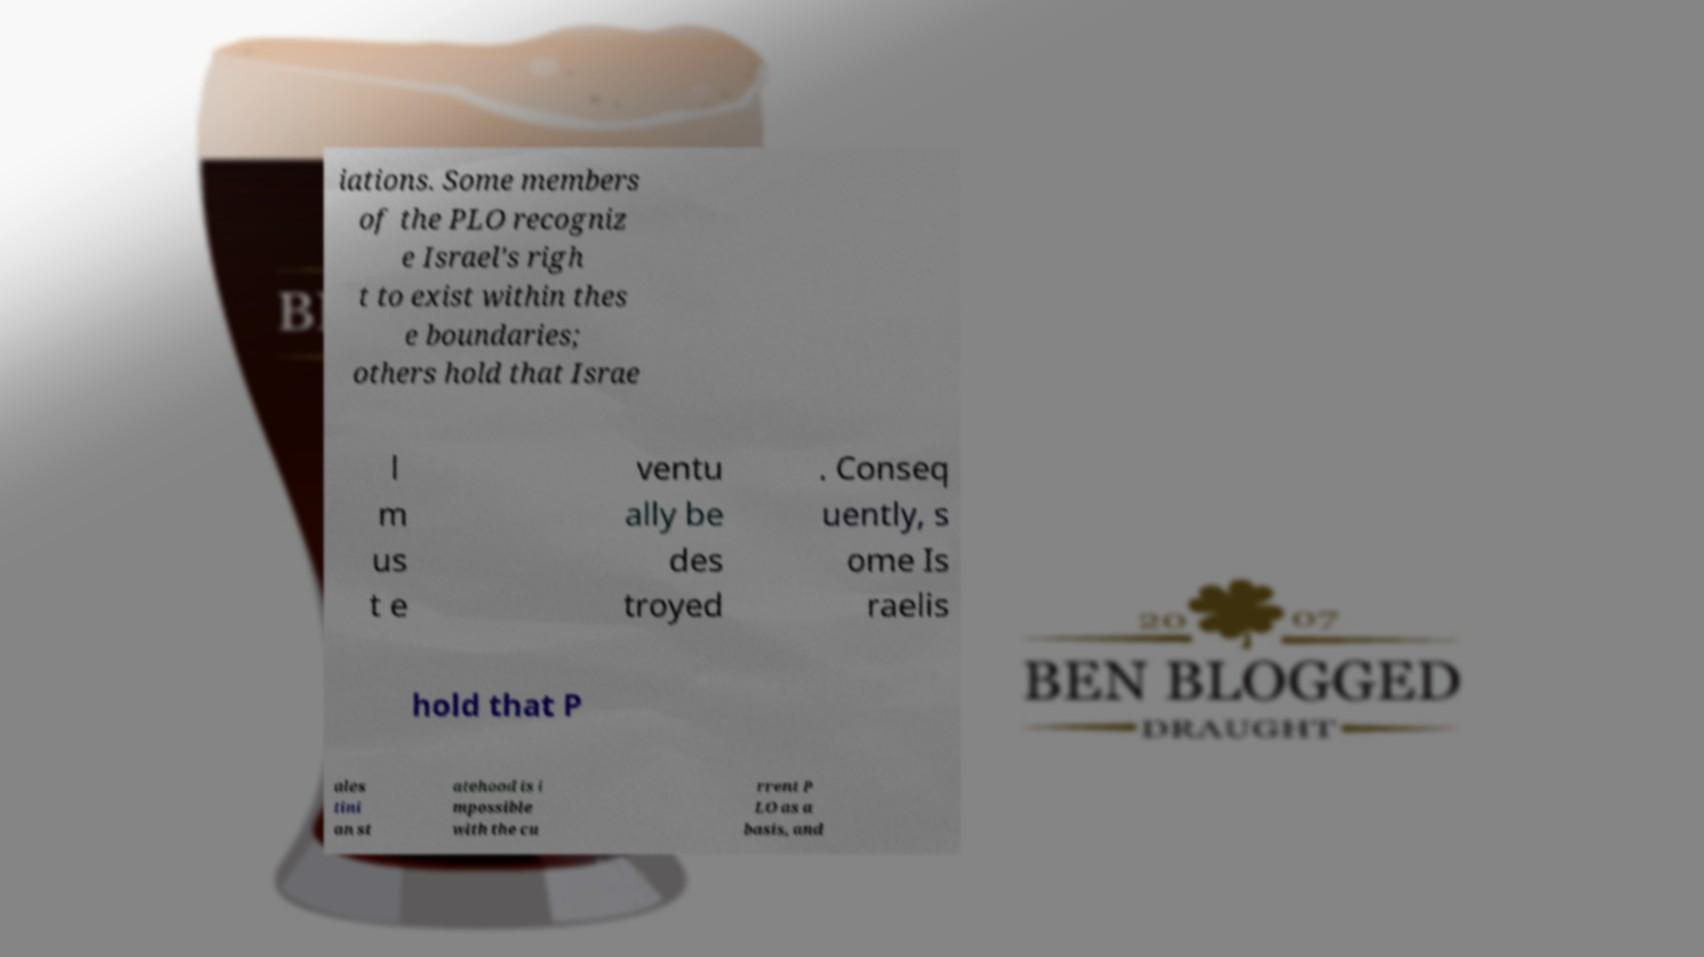Could you extract and type out the text from this image? iations. Some members of the PLO recogniz e Israel's righ t to exist within thes e boundaries; others hold that Israe l m us t e ventu ally be des troyed . Conseq uently, s ome Is raelis hold that P ales tini an st atehood is i mpossible with the cu rrent P LO as a basis, and 